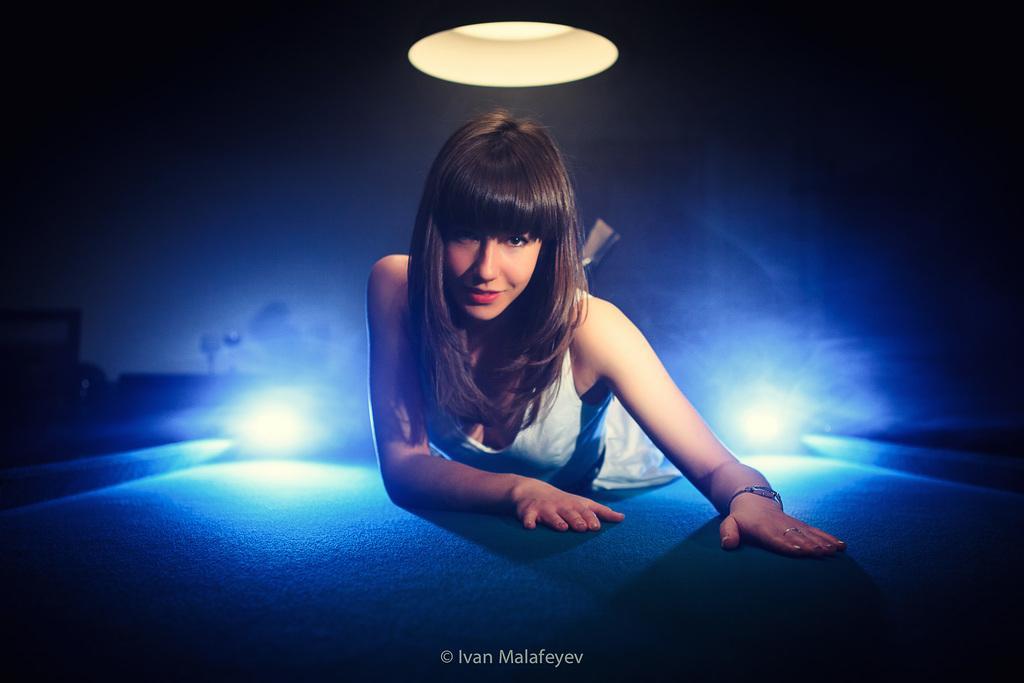Can you describe this image briefly? In this image we can see one light at the top of the image, some text on the bottom of the image, one woman with a smiling face lying on the floor in the middle of the image, two lights on the floor, few objects in the background and the image is dark. 